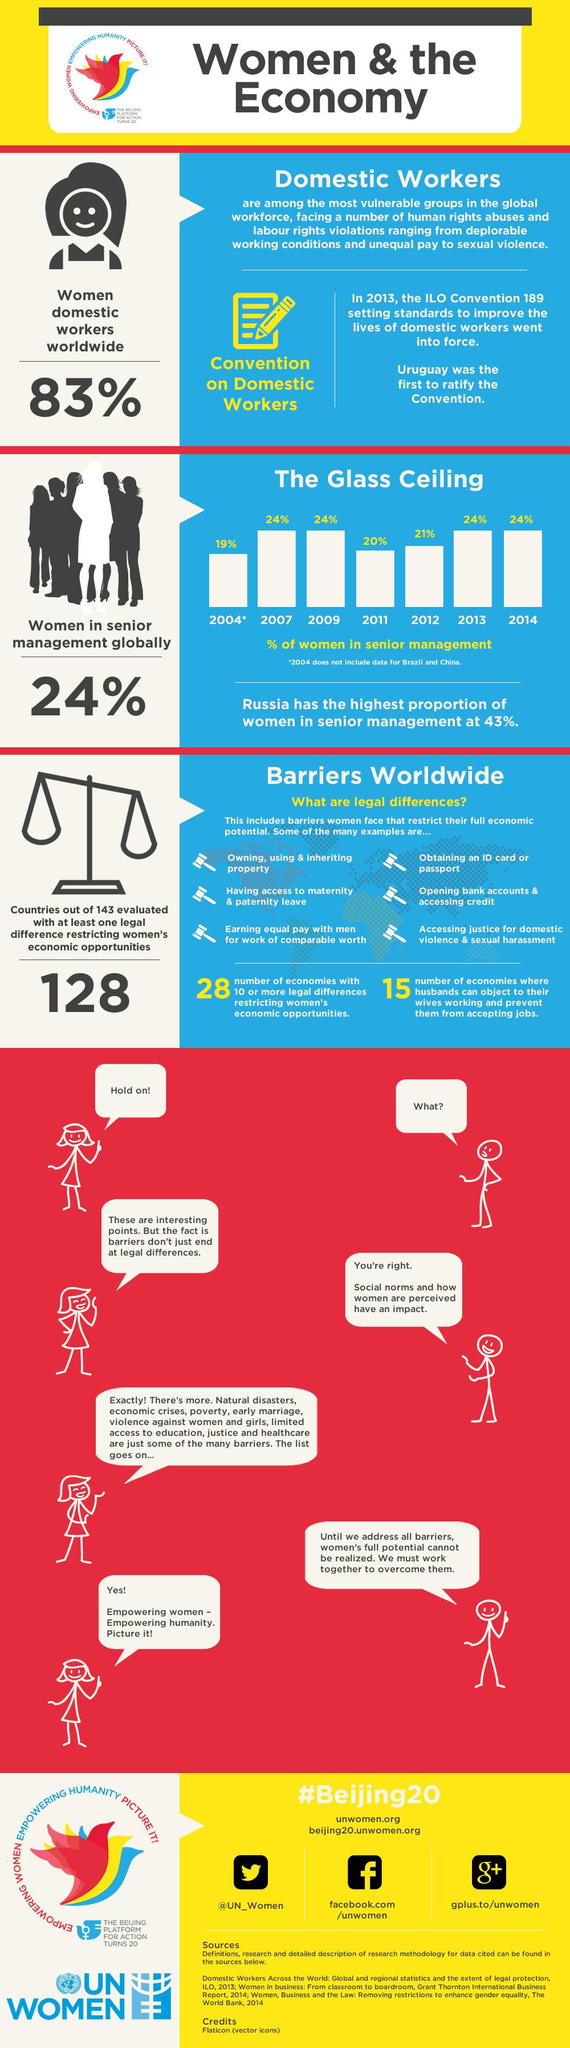Give some essential details in this illustration. Uruguay was the first country to ratify the ILO domestic work Convention. In 2012, globally, only 21% of women held positions in senior management. According to recent global statistics, an overwhelming 83% of women worldwide are employed as domestic workers. Of the 143 countries evaluated, 128 have at least one legal difference that restricts women's economic opportunities. There are 28 economies with more than 10 legal differences that restrict women's economic opportunities. 